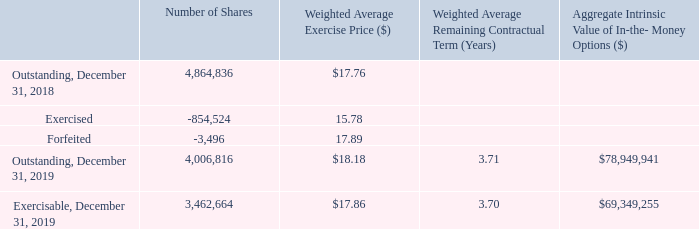Stock Options
Stock options granted pursuant to the 2016 Incentive Plan are granted at an exercise price not less than the market value per share of the Company’s common stock on the date of grant. Under the 2016 Incentive Plan, the term of the outstanding options may not exceed ten years nor be less than one year. Vesting of options is determined by the compensation committee of the board and the administrator of the 2016 Incentive Plan and can vary based upon the individual award agreements. In addition, outstanding options do not have dividend equivalent rights associated with them under the 2016 Incentive Plan.
A summary of stock option activity is as follows:
The weighted average grant date fair value of stock options granted during the years ended December 31, 2018 and 2017, was $7.03 and $6.24, respectively. The Company did not grant stock options during the year ended December 31, 2019. The total intrinsic value of stock options exercised during the years ended December 31, 2019, 2018, and 2017, was $16.0 million, $15.8 million, and $13.4 million, respectively.
What were the number of shares Exercised in 2018? 854,524. What was the weighted average grant date fair value of stock options granted during the years ended December 31, 2018? $7.03. What was the weighted average grant date fair value of stock options granted during the years ended December 31, 2017? $6.24. What is the difference in the Weighted Average Exercise Price between Exercised and Forfeited stock options? 17.89-15.78
Answer: 2.11. What is the change in the number of shares between outstanding and exercisable stock options as of December 31, 2019? 4,006,816-3,462,664
Answer: 544152. What is the difference in the Weighted Average Exercise Price between Exercised and Outstanding stock options in 2018? $17.76-15.78
Answer: 1.98. 